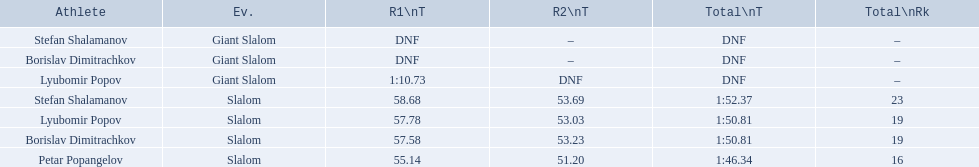What are all the competitions lyubomir popov competed in? Lyubomir Popov, Lyubomir Popov. Of those, which were giant slalom races? Giant Slalom. What was his time in race 1? 1:10.73. 